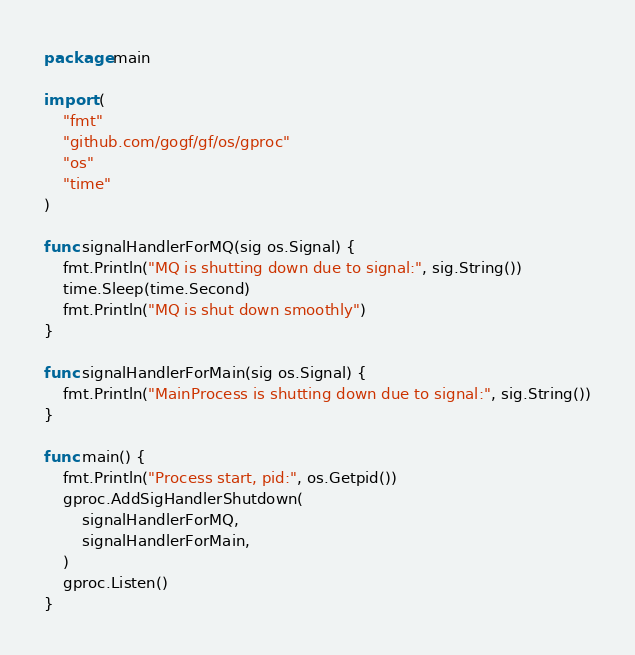<code> <loc_0><loc_0><loc_500><loc_500><_Go_>package main

import (
	"fmt"
	"github.com/gogf/gf/os/gproc"
	"os"
	"time"
)

func signalHandlerForMQ(sig os.Signal) {
	fmt.Println("MQ is shutting down due to signal:", sig.String())
	time.Sleep(time.Second)
	fmt.Println("MQ is shut down smoothly")
}

func signalHandlerForMain(sig os.Signal) {
	fmt.Println("MainProcess is shutting down due to signal:", sig.String())
}

func main() {
	fmt.Println("Process start, pid:", os.Getpid())
	gproc.AddSigHandlerShutdown(
		signalHandlerForMQ,
		signalHandlerForMain,
	)
	gproc.Listen()
}
</code> 